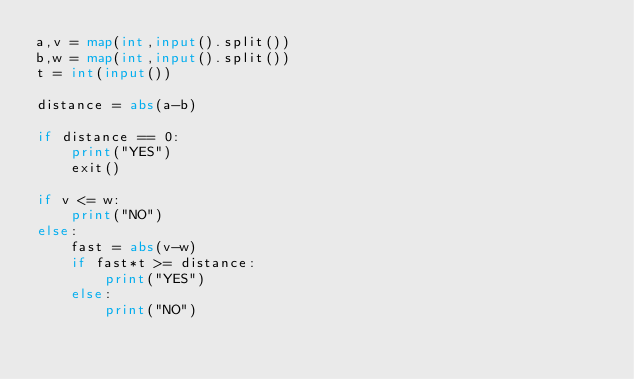<code> <loc_0><loc_0><loc_500><loc_500><_Python_>a,v = map(int,input().split())
b,w = map(int,input().split())
t = int(input())

distance = abs(a-b)

if distance == 0:
    print("YES")
    exit()

if v <= w:
    print("NO")
else:
    fast = abs(v-w)
    if fast*t >= distance:
        print("YES")
    else:
        print("NO")
</code> 